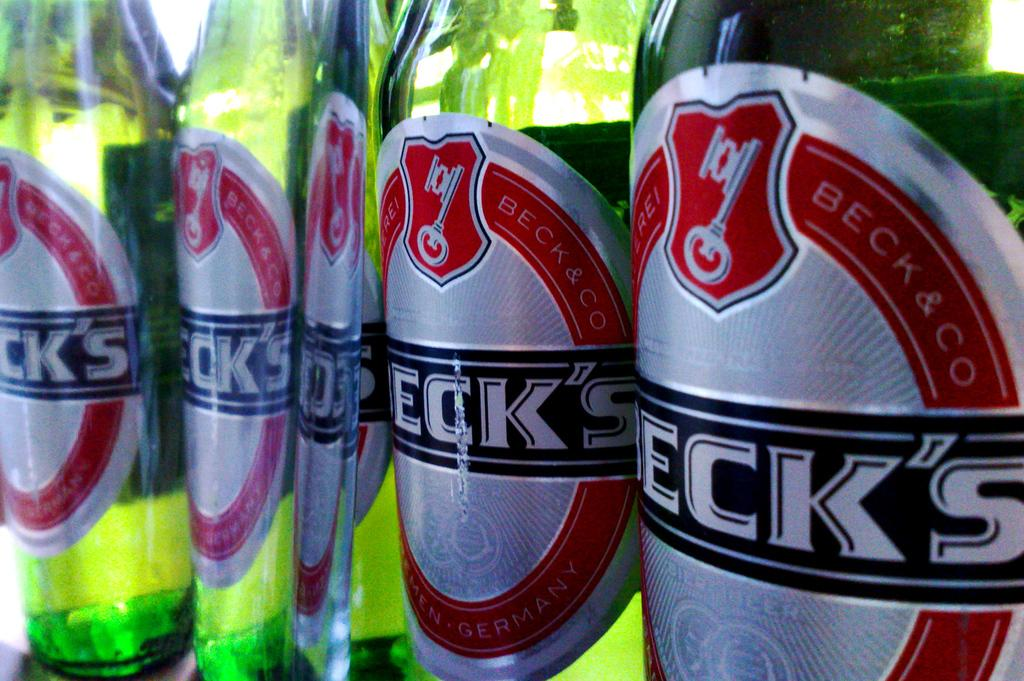<image>
Give a short and clear explanation of the subsequent image. Beck & Co beer bottles are shown close up. 